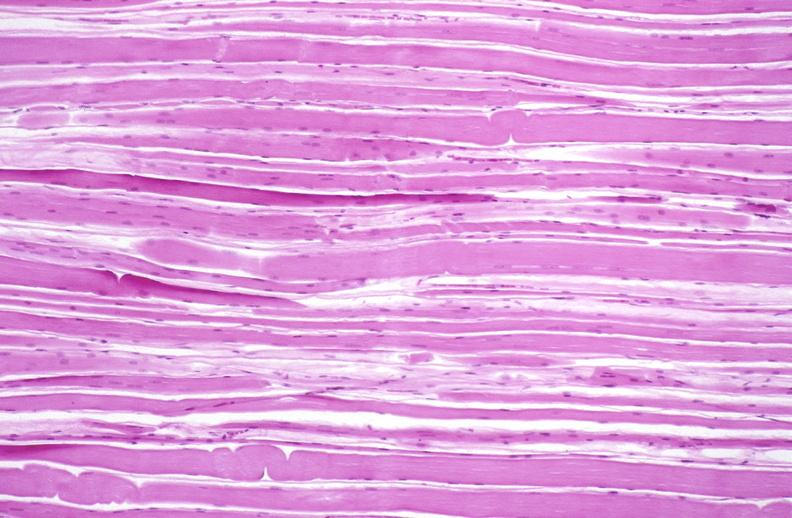does this image show skeletal muscle atrophy?
Answer the question using a single word or phrase. Yes 